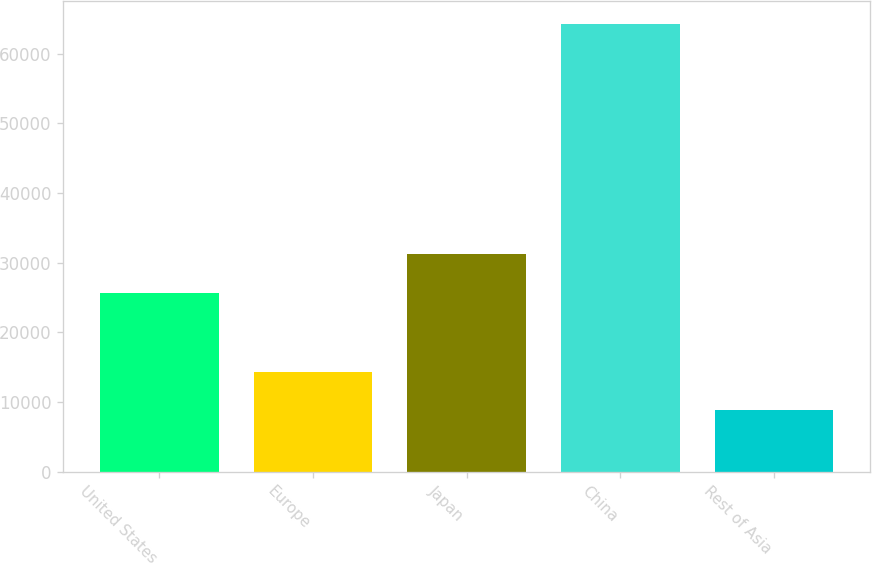Convert chart to OTSL. <chart><loc_0><loc_0><loc_500><loc_500><bar_chart><fcel>United States<fcel>Europe<fcel>Japan<fcel>China<fcel>Rest of Asia<nl><fcel>25650<fcel>14381<fcel>31200<fcel>64325<fcel>8825<nl></chart> 